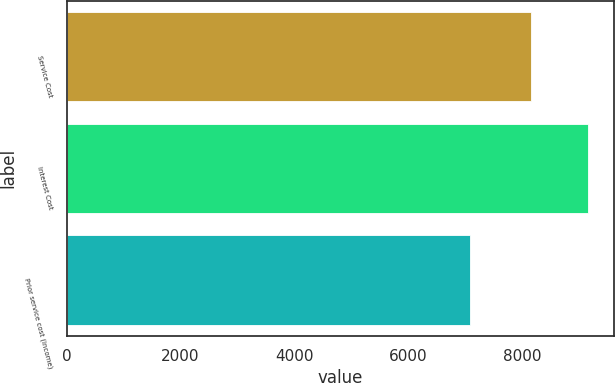Convert chart to OTSL. <chart><loc_0><loc_0><loc_500><loc_500><bar_chart><fcel>Service Cost<fcel>Interest Cost<fcel>Prior service cost (income)<nl><fcel>8156<fcel>9146<fcel>7086<nl></chart> 